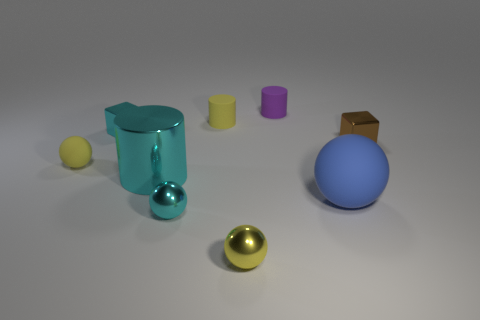Add 1 small gray shiny blocks. How many objects exist? 10 Subtract all balls. How many objects are left? 5 Subtract 0 red cylinders. How many objects are left? 9 Subtract all brown things. Subtract all tiny purple things. How many objects are left? 7 Add 3 large cylinders. How many large cylinders are left? 4 Add 3 large red things. How many large red things exist? 3 